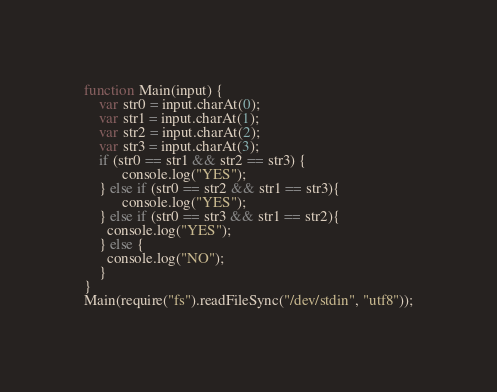Convert code to text. <code><loc_0><loc_0><loc_500><loc_500><_JavaScript_>function Main(input) {
	var str0 = input.charAt(0);
  	var str1 = input.charAt(1);
  	var str2 = input.charAt(2);
  	var str3 = input.charAt(3);
  	if (str0 == str1 && str2 == str3) {
          console.log("YES");
    } else if (str0 == str2 && str1 == str3){
          console.log("YES");
   	} else if (str0 == str3 && str1 == str2){
	  console.log("YES");
    } else {
      console.log("NO");
    }
}
Main(require("fs").readFileSync("/dev/stdin", "utf8"));</code> 